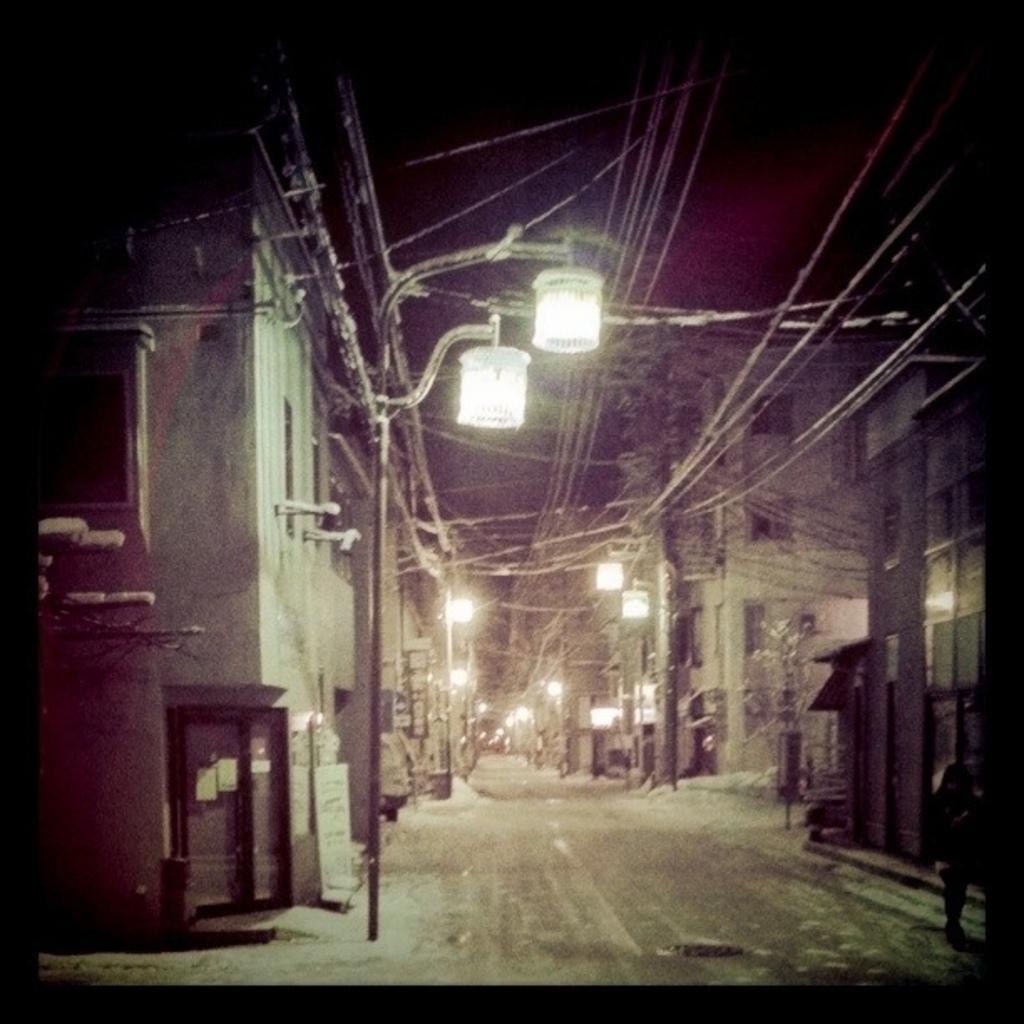Can you describe this image briefly? In this picture we can see a street lights, electric poles and road. On the right we can see buildings. On the left there is a door which is near to the street light. 